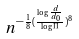Convert formula to latex. <formula><loc_0><loc_0><loc_500><loc_500>n ^ { - \frac { 1 } { 8 } ( \frac { \log \frac { d } { d _ { 0 } } } { \log \Pi } ) ^ { 8 } }</formula> 